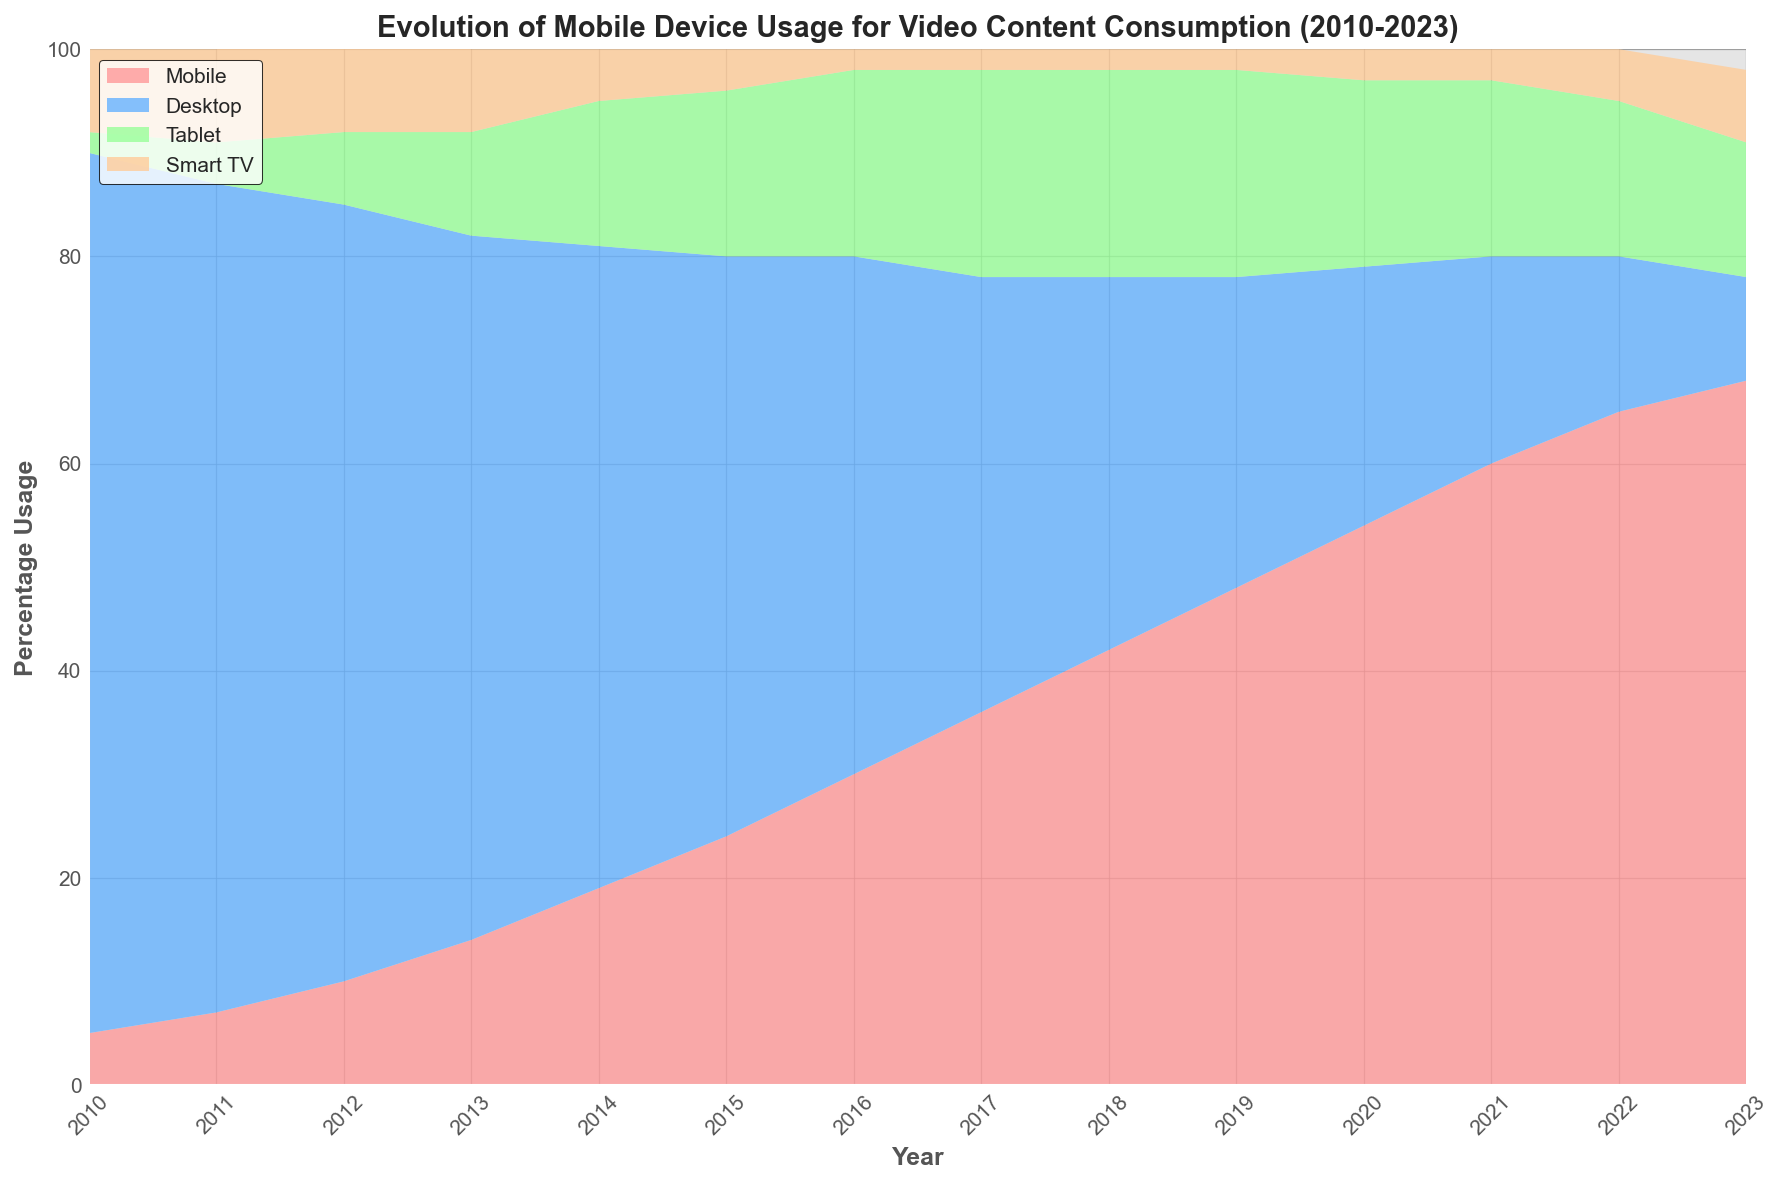What was the percentage usage of mobile devices in 2015? Look for the mobile usage percentage in 2015 on the area chart. The mobile usage is 24%.
Answer: 24% How has desktop usage changed from 2010 to 2023? Observe the trend of desktop usage from 2010 to 2023. Desktop usage has consistently decreased from 85% in 2010 to 10% in 2023.
Answer: Decreased Which year had the highest percentage of mobile usage, and what was the percentage? Identify the highest point in the 'Mobile' section of the area chart and note its corresponding year. The highest percentage of mobile usage is 68% in 2023.
Answer: 2023, 68% Compare the percentage usage of tablets and smart TVs in 2020. Which one was higher? Check the percentages for tablets and smart TVs in the year 2020 on the area chart. The tablet usage is 18%, and the smart TV usage is 3%, so tablets had higher usage.
Answer: Tablets Calculate the total percentage of video content consumption on mobile devices from 2010 to 2023. Sum the mobile usage percentages for each year from 2010 to 2023. The total percentage is 5 + 7 + 10 + 14 + 19 + 24 + 30 + 36 + 42 + 48 + 54 + 60 + 65 + 68 = 482%.
Answer: 482% What is the difference in desktop usage between 2010 and 2023? Subtract the desktop usage percentage in 2023 from the desktop usage percentage in 2010. The difference is 85% - 10% = 75%.
Answer: 75% Which device category showed the least variation in usage from 2010 to 2023? Look at the trend lines for all four device categories and see which one has the smallest range of change. The smart TV usage shows the least variation, fluctuating between 2% and 8%.
Answer: Smart TV In which years did tablet usage peak, and what was the percentage usage at its peak? Identify the highest point in the 'Tablet' section of the area chart and note the corresponding years. Tablet usage peaked at 20% from 2017 to 2019.
Answer: 2017-2019, 20% Compare the trend of mobile and desktop usage between 2012 and 2015. How are they different? Examine the patterns for mobile and desktop usage from 2012 to 2015. Mobile usage increased from 10% to 24%, while desktop usage decreased from 75% to 56%.
Answer: Mobile: Increased, Desktop: Decreased 